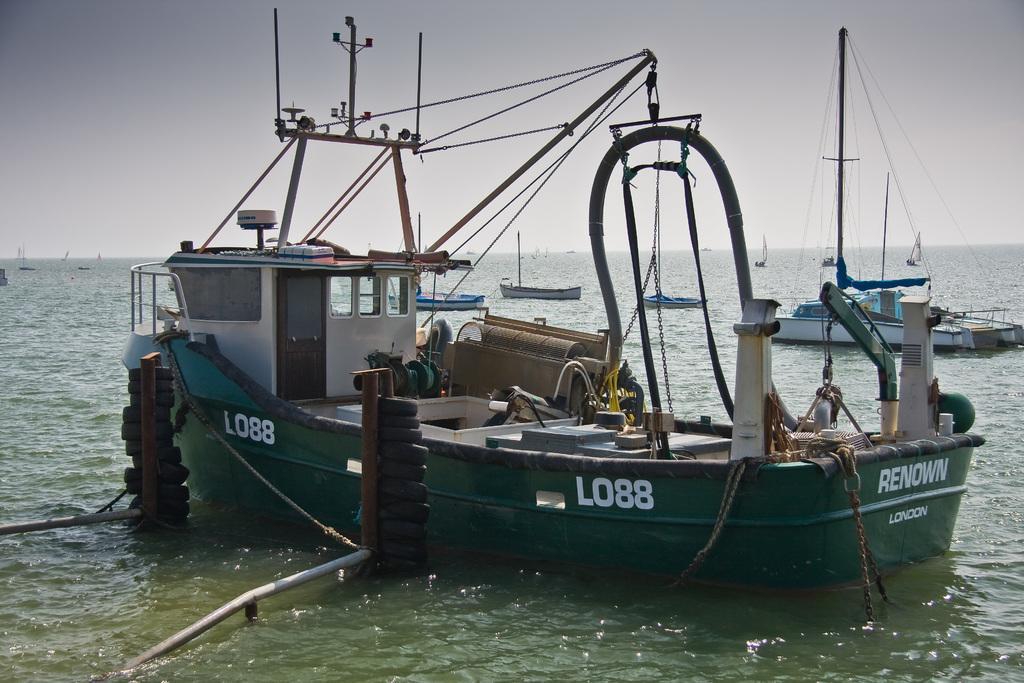Please provide a concise description of this image. In this image, I can see boats on the water. This looks like an iron chain, which is hanging to the boat. These are the tires, which are on the iron roads. I think this is the sea. This looks like a door. I think this is a small cabin with glass windows. 